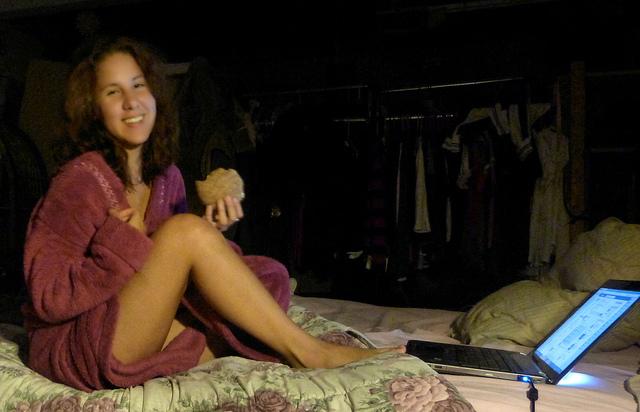Is she eating in bed?
Concise answer only. Yes. What is she sitting on?
Be succinct. Bed. Is the laptop on?
Give a very brief answer. Yes. What color is her hair?
Short answer required. Brown. What is the person holding?
Give a very brief answer. Food. Is this woman trying to look cool by sitting in an awkward position?
Quick response, please. Yes. Is the computer on?
Be succinct. Yes. In what position are the woman's thumbs?
Write a very short answer. Up. 